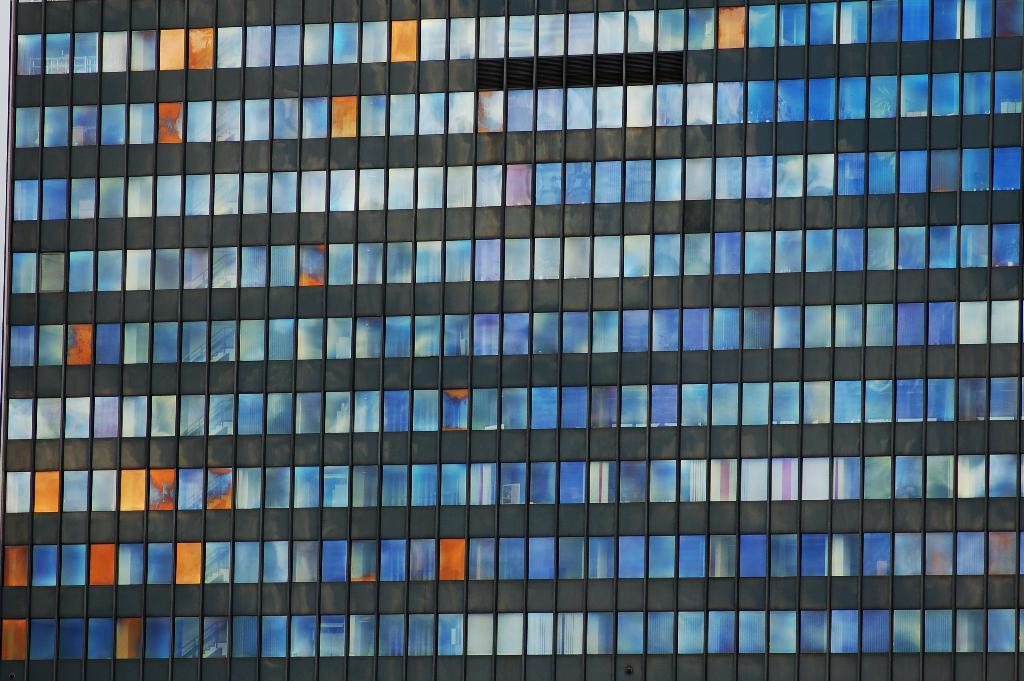What is the main structure visible in the image? There is a building in the image. Can you describe any specific features of the building? The building has many window glasses. What type of farm animals can be seen in the image? There are no farm animals present in the image; it features a building with many window glasses. Is the sister of the person taking the photo visible in the image? There is no information about the person taking the photo or their sister, so it cannot be determined if she is visible in the image. 